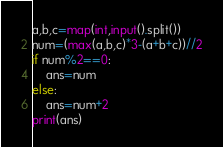<code> <loc_0><loc_0><loc_500><loc_500><_Python_>a,b,c=map(int,input().split())
num=(max(a,b,c)*3-(a+b+c))//2
if num%2==0:
    ans=num
else:
    ans=num+2
print(ans)
</code> 